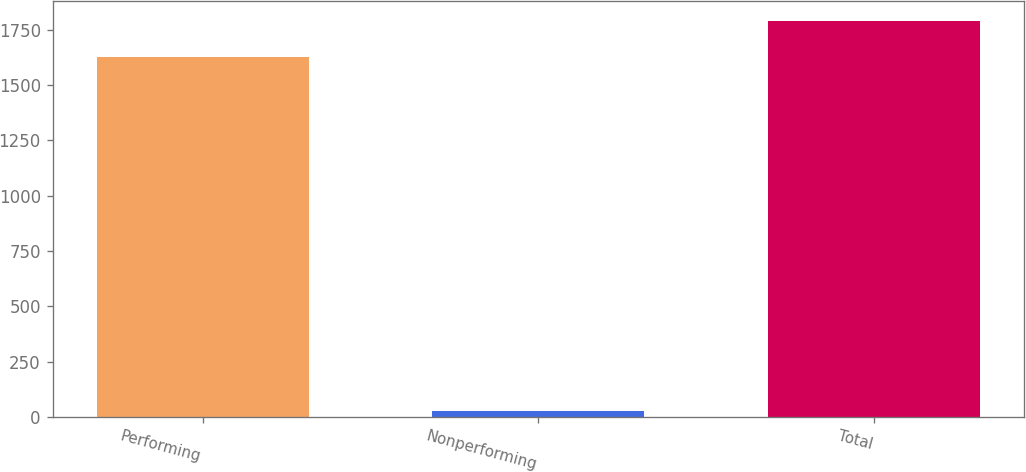<chart> <loc_0><loc_0><loc_500><loc_500><bar_chart><fcel>Performing<fcel>Nonperforming<fcel>Total<nl><fcel>1626.4<fcel>27.9<fcel>1789.04<nl></chart> 